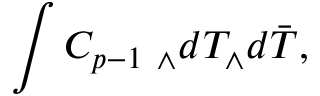<formula> <loc_0><loc_0><loc_500><loc_500>\int C _ { p - 1 } _ { \wedge } d T _ { \wedge } d \bar { T } ,</formula> 